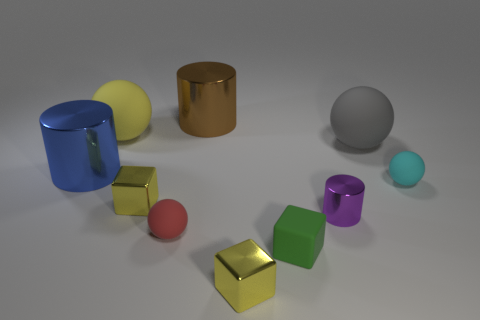Subtract 1 spheres. How many spheres are left? 3 Subtract all cylinders. How many objects are left? 7 Subtract all small cyan matte objects. Subtract all cyan rubber objects. How many objects are left? 8 Add 5 purple cylinders. How many purple cylinders are left? 6 Add 1 green matte spheres. How many green matte spheres exist? 1 Subtract 0 brown spheres. How many objects are left? 10 